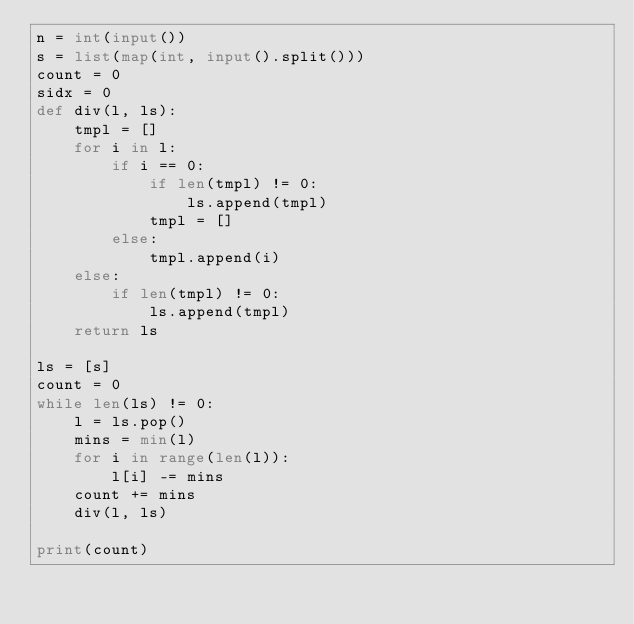Convert code to text. <code><loc_0><loc_0><loc_500><loc_500><_Python_>n = int(input())
s = list(map(int, input().split()))
count = 0
sidx = 0
def div(l, ls):
    tmpl = []
    for i in l:
        if i == 0:
            if len(tmpl) != 0:
                ls.append(tmpl)
            tmpl = []
        else:
            tmpl.append(i)
    else:
        if len(tmpl) != 0:
            ls.append(tmpl)
    return ls

ls = [s]
count = 0
while len(ls) != 0:
    l = ls.pop()
    mins = min(l)
    for i in range(len(l)):
        l[i] -= mins
    count += mins
    div(l, ls)

print(count)</code> 